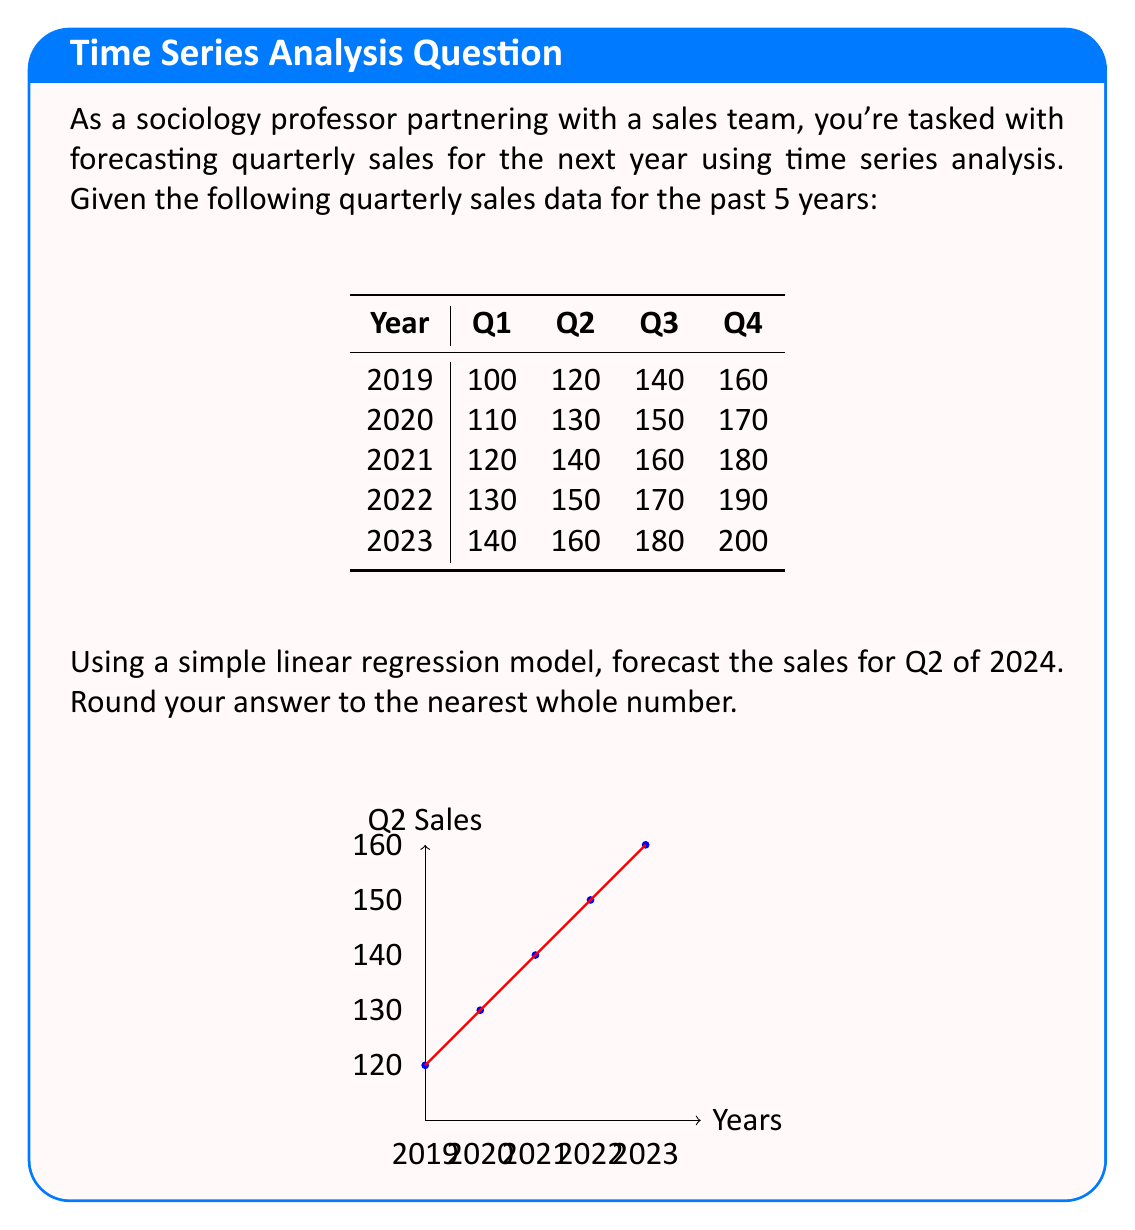Can you answer this question? To forecast the sales for Q2 of 2024 using a simple linear regression model, we'll follow these steps:

1) First, let's set up our data:
   x (years): 0, 1, 2, 3, 4 (representing 2019 to 2023)
   y (Q2 sales): 120, 130, 140, 150, 160

2) We'll use the linear regression formula: $y = mx + b$, where $m$ is the slope and $b$ is the y-intercept.

3) To find $m$ and $b$, we'll use these formulas:
   $m = \frac{n\sum xy - \sum x \sum y}{n\sum x^2 - (\sum x)^2}$
   $b = \frac{\sum y - m\sum x}{n}$

   Where $n$ is the number of data points (5 in this case).

4) Let's calculate the necessary sums:
   $\sum x = 0 + 1 + 2 + 3 + 4 = 10$
   $\sum y = 120 + 130 + 140 + 150 + 160 = 700$
   $\sum xy = (0 * 120) + (1 * 130) + (2 * 140) + (3 * 150) + (4 * 160) = 1600$
   $\sum x^2 = 0^2 + 1^2 + 2^2 + 3^2 + 4^2 = 30$

5) Now, let's calculate $m$:
   $m = \frac{5(1600) - 10(700)}{5(30) - 10^2} = \frac{8000 - 7000}{150 - 100} = \frac{1000}{50} = 20$

6) And $b$:
   $b = \frac{700 - 20(10)}{5} = \frac{700 - 200}{5} = 100$

7) Our regression equation is therefore: $y = 20x + 100$

8) To forecast Q2 sales for 2024, we need to use $x = 5$ (as 2024 is 5 years after 2019):
   $y = 20(5) + 100 = 200$

Therefore, the forecasted sales for Q2 of 2024 is 200.
Answer: 200 